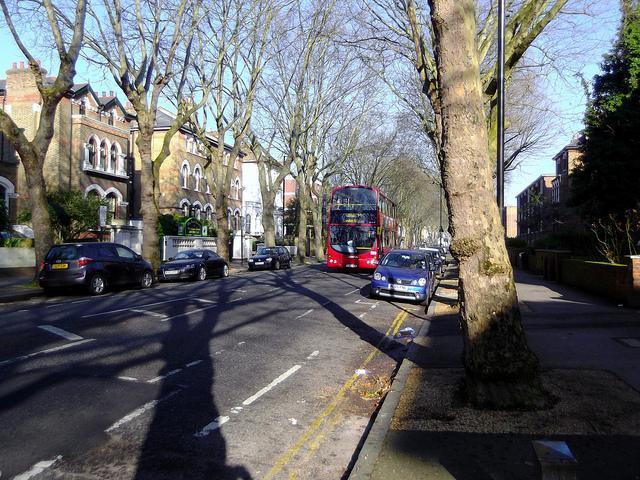How many blue flags are there?
Give a very brief answer. 0. How many cars are there?
Give a very brief answer. 2. How many people are wearing a hat?
Give a very brief answer. 0. 